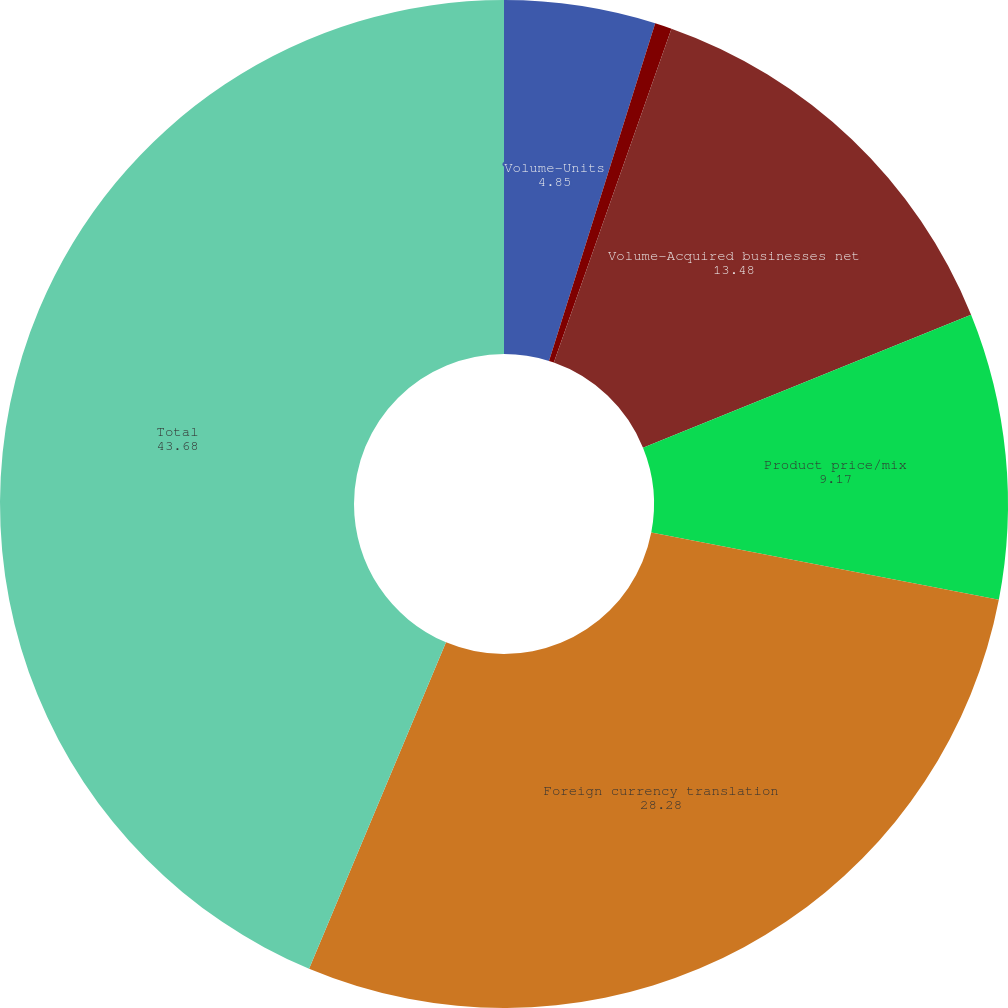Convert chart. <chart><loc_0><loc_0><loc_500><loc_500><pie_chart><fcel>Volume-Units<fcel>change<fcel>Volume-Acquired businesses net<fcel>Product price/mix<fcel>Foreign currency translation<fcel>Total<nl><fcel>4.85%<fcel>0.54%<fcel>13.48%<fcel>9.17%<fcel>28.28%<fcel>43.68%<nl></chart> 